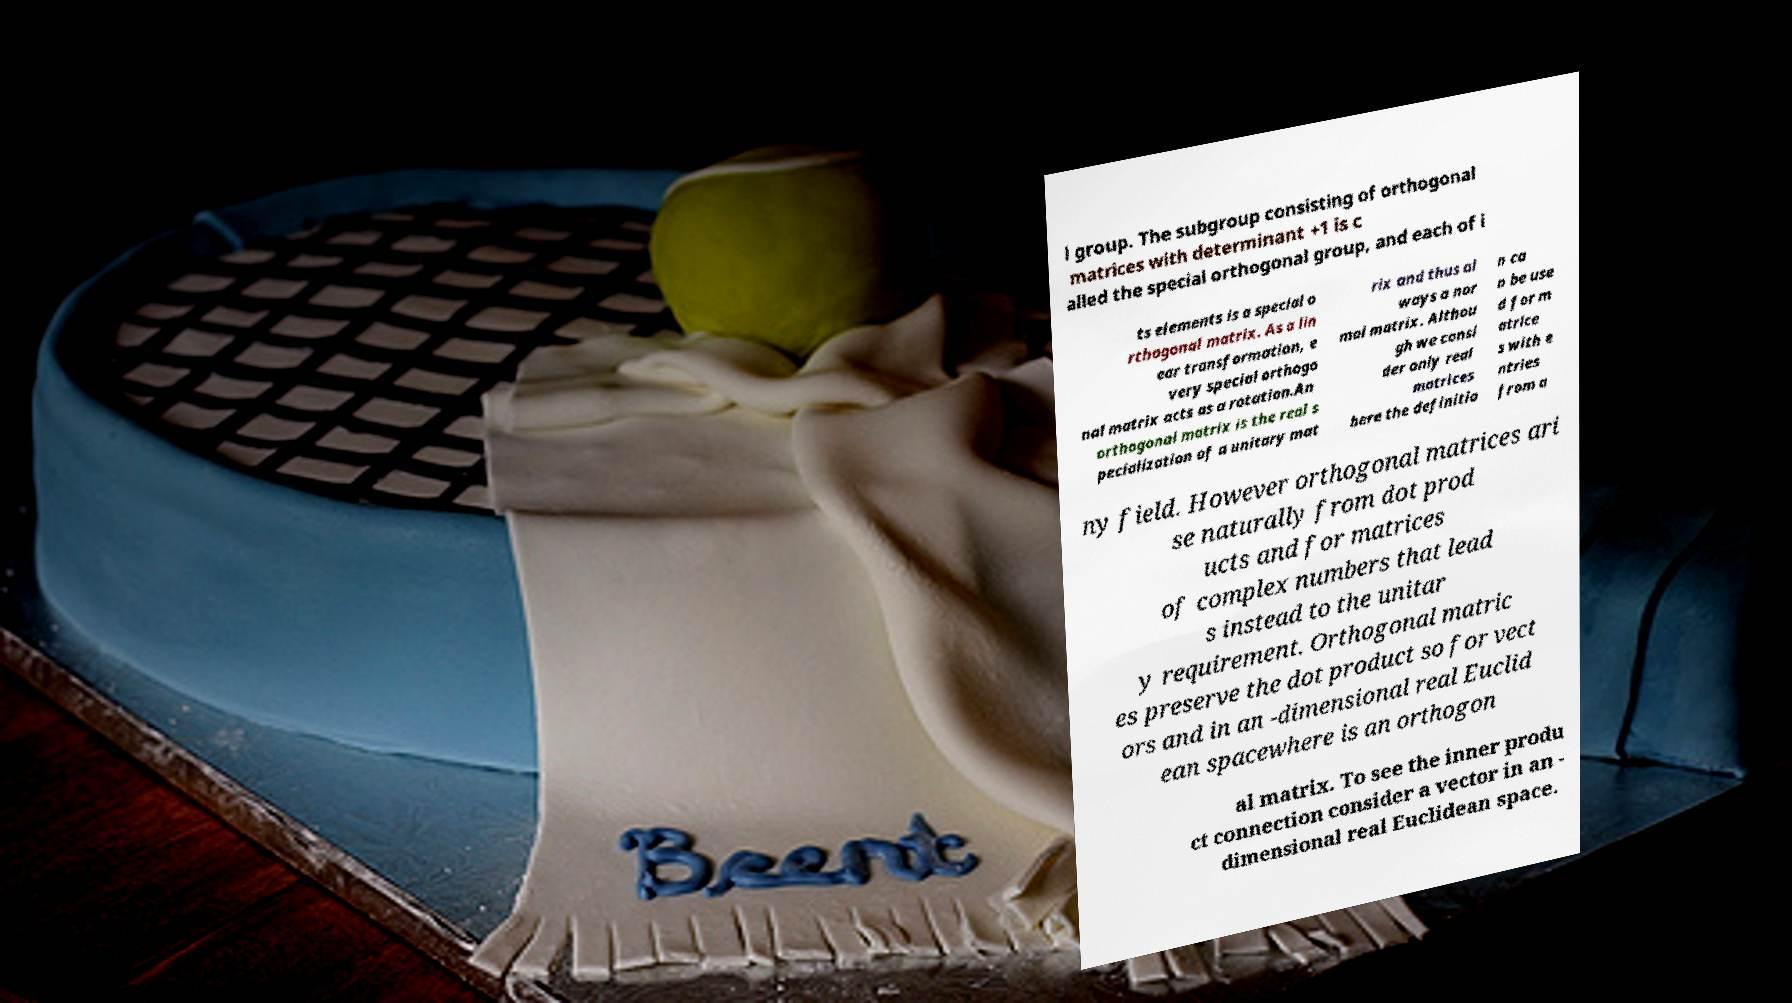Can you accurately transcribe the text from the provided image for me? l group. The subgroup consisting of orthogonal matrices with determinant +1 is c alled the special orthogonal group, and each of i ts elements is a special o rthogonal matrix. As a lin ear transformation, e very special orthogo nal matrix acts as a rotation.An orthogonal matrix is the real s pecialization of a unitary mat rix and thus al ways a nor mal matrix. Althou gh we consi der only real matrices here the definitio n ca n be use d for m atrice s with e ntries from a ny field. However orthogonal matrices ari se naturally from dot prod ucts and for matrices of complex numbers that lead s instead to the unitar y requirement. Orthogonal matric es preserve the dot product so for vect ors and in an -dimensional real Euclid ean spacewhere is an orthogon al matrix. To see the inner produ ct connection consider a vector in an - dimensional real Euclidean space. 